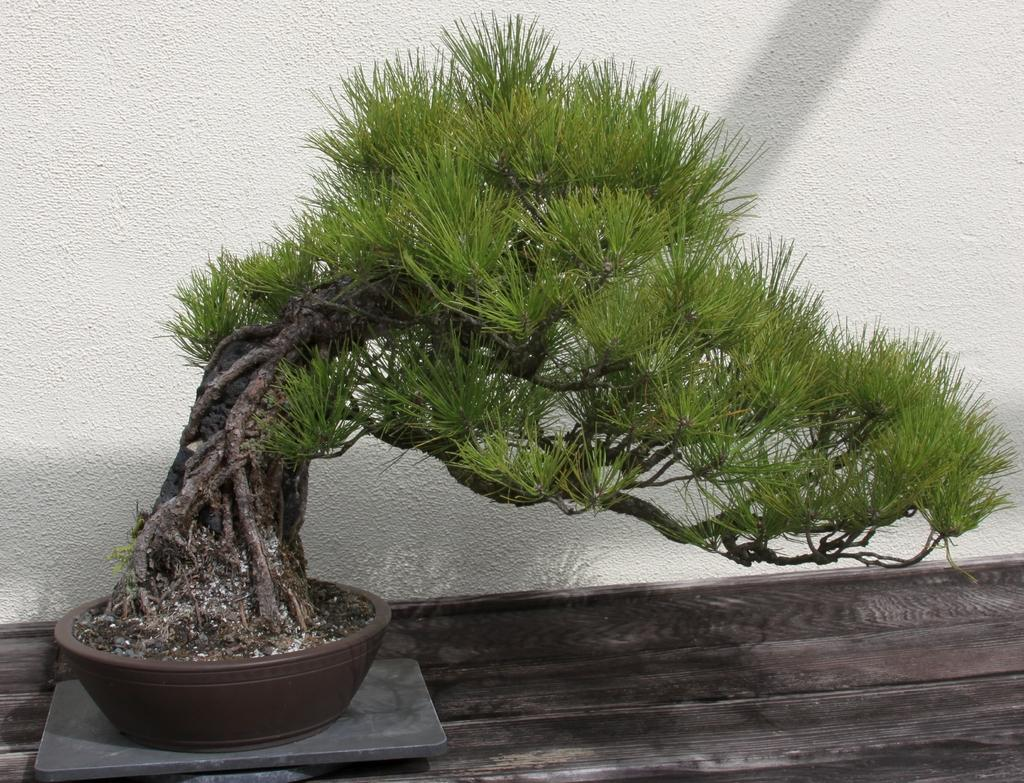Where was the image taken? The image is taken indoors. What piece of furniture is present in the image? There is a table in the image. What is placed on the table? There is a pot on the table. What is inside the pot? There is a plant in the pot. Can you see any fog in the image? There is no fog present in the image. What type of spoon is used to water the plant in the image? There is no spoon visible in the image; the plant is in a pot with soil. 